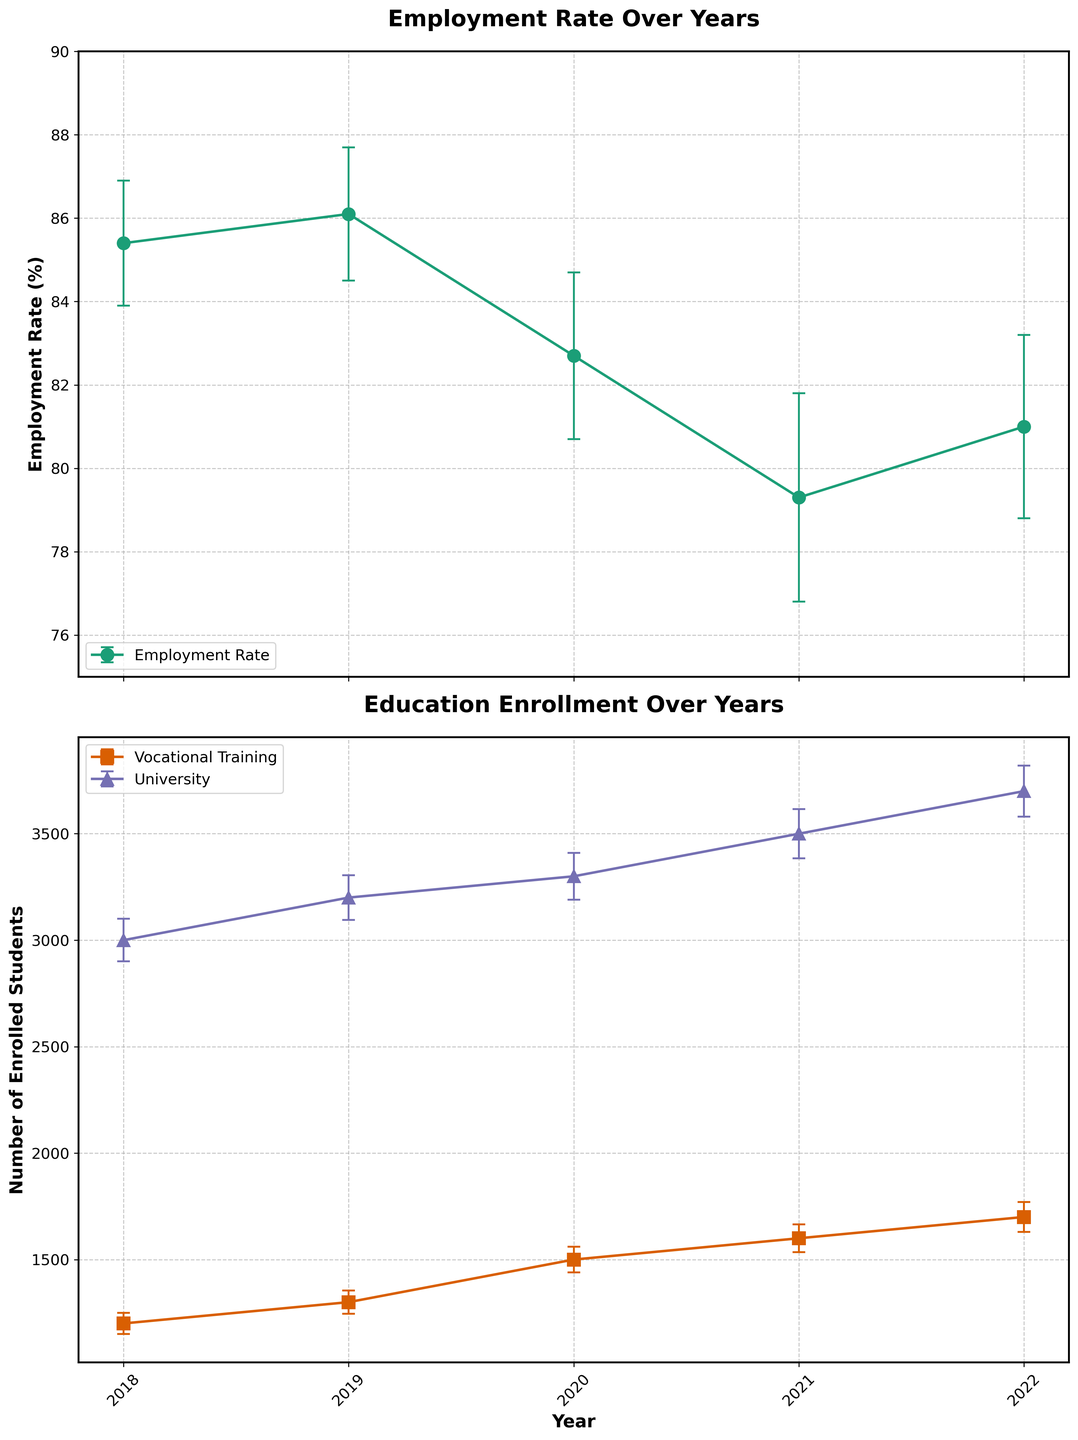What is the title of the first subplot? The title of the first subplot is written above the first graph.
Answer: Employment Rate Over Years What is the highest employment rate recorded over the five years? The highest employment rate can be identified by looking at the peaks of the line on the first subplot.
Answer: 86.1% How many students were enrolled in vocational training in 2020? The number of students can be read off the second subplot at the year 2020 bar labeled 'Vocational Training'.
Answer: 1500 Which year had the lowest employment rate, and what was that rate? The lowest employment rate is identified by finding the lowest point on the line in the first subplot along the x-axis representing years.
Answer: 2021, 79.3% Which enrollment category had a higher number of students in 2021, vocational training or university? Compare the y-values of the two lines in the second subplot for the year 2021.
Answer: University How did the employment rate change from 2020 to 2021? Calculate the difference between the employment rates for 2020 and 2021 based on the y-values of the first subplot at these years.
Answer: Decreased by 3.4% What trend do you observe in university enrollment over the five years? Look at the second subplot and observe if the line labeled 'University' generally increases, decreases, or stays the same from 2018 to 2022.
Answer: Increasing What is the average employment rate over the five years? Sum the employment rates for each year and divide by the number of years, i.e., (85.4 + 86.1 + 82.7 + 79.3 + 81.0) / 5.
Answer: 82.9% Which year shows the largest error bar for employment rate? Identify the longest error bar on the first subplot along the y-axis representing errors for different years.
Answer: 2021 Is there any year where the employment rate falls outside the error bars of the previous year? If so, which year? Compare the employment rate and error bars year by year to see if the current year's rate falls outside the previous year's error bars.
Answer: Yes, 2021 